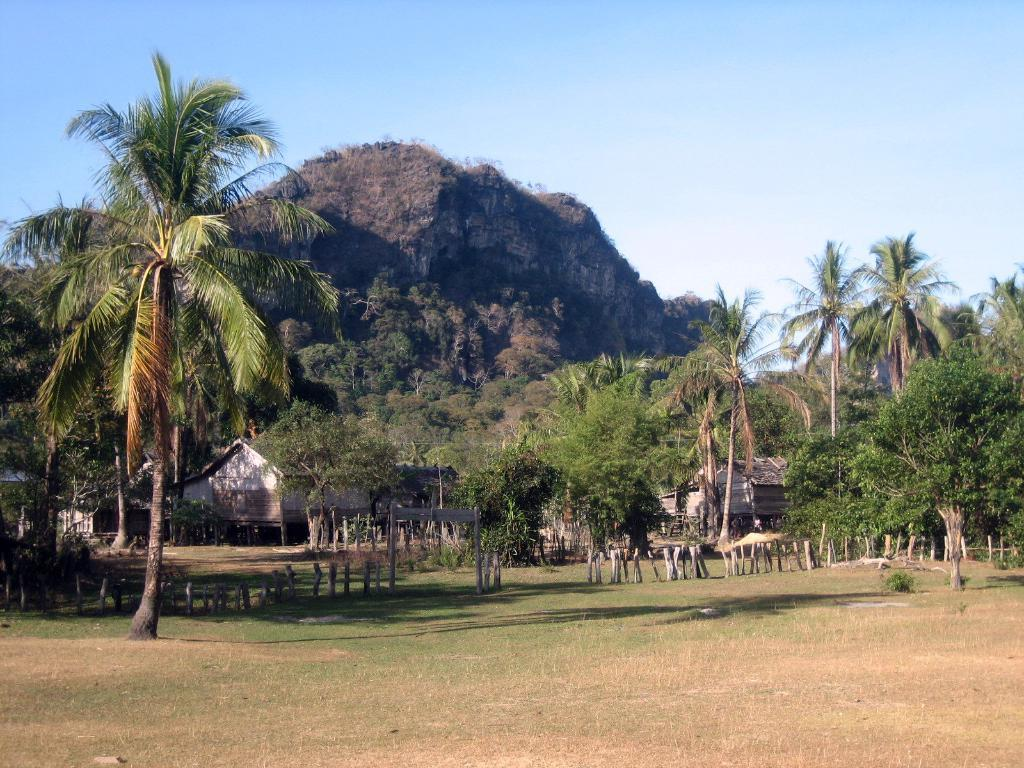What type of natural elements can be seen in the image? There are trees in the image. What type of man-made structures are present in the image? There are houses in the image. What geographical feature is visible in the image? There is a mountain in the image. What color is the scarf draped over the mountain in the image? There is no scarf present in the image; it only features trees, houses, and a mountain. What type of punishment is being administered to the trees in the image? There is no punishment being administered to the trees in the image; they are simply standing in their natural state. 